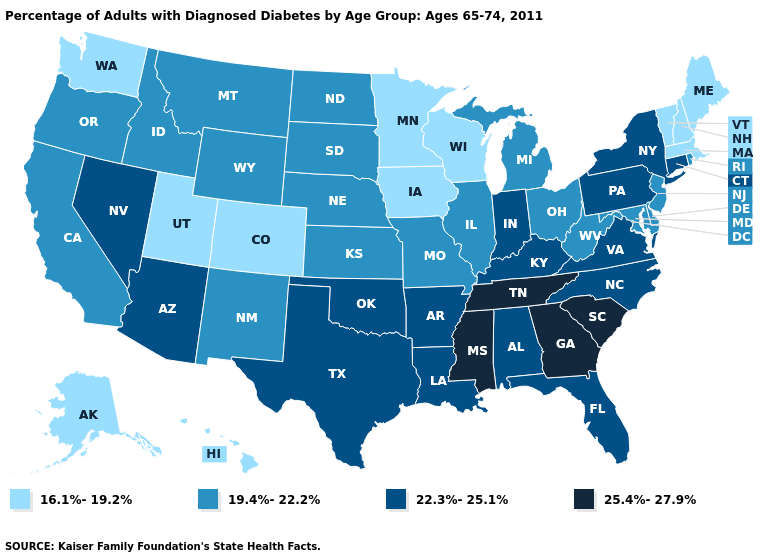Does the map have missing data?
Short answer required. No. What is the highest value in the South ?
Give a very brief answer. 25.4%-27.9%. What is the value of Wyoming?
Be succinct. 19.4%-22.2%. What is the value of Connecticut?
Short answer required. 22.3%-25.1%. What is the value of South Dakota?
Quick response, please. 19.4%-22.2%. Name the states that have a value in the range 25.4%-27.9%?
Be succinct. Georgia, Mississippi, South Carolina, Tennessee. What is the value of Oklahoma?
Give a very brief answer. 22.3%-25.1%. Name the states that have a value in the range 19.4%-22.2%?
Answer briefly. California, Delaware, Idaho, Illinois, Kansas, Maryland, Michigan, Missouri, Montana, Nebraska, New Jersey, New Mexico, North Dakota, Ohio, Oregon, Rhode Island, South Dakota, West Virginia, Wyoming. What is the highest value in states that border Massachusetts?
Keep it brief. 22.3%-25.1%. Which states have the lowest value in the USA?
Answer briefly. Alaska, Colorado, Hawaii, Iowa, Maine, Massachusetts, Minnesota, New Hampshire, Utah, Vermont, Washington, Wisconsin. Among the states that border Louisiana , does Texas have the highest value?
Short answer required. No. Name the states that have a value in the range 19.4%-22.2%?
Answer briefly. California, Delaware, Idaho, Illinois, Kansas, Maryland, Michigan, Missouri, Montana, Nebraska, New Jersey, New Mexico, North Dakota, Ohio, Oregon, Rhode Island, South Dakota, West Virginia, Wyoming. What is the lowest value in the West?
Short answer required. 16.1%-19.2%. What is the value of Connecticut?
Give a very brief answer. 22.3%-25.1%. Name the states that have a value in the range 22.3%-25.1%?
Concise answer only. Alabama, Arizona, Arkansas, Connecticut, Florida, Indiana, Kentucky, Louisiana, Nevada, New York, North Carolina, Oklahoma, Pennsylvania, Texas, Virginia. 